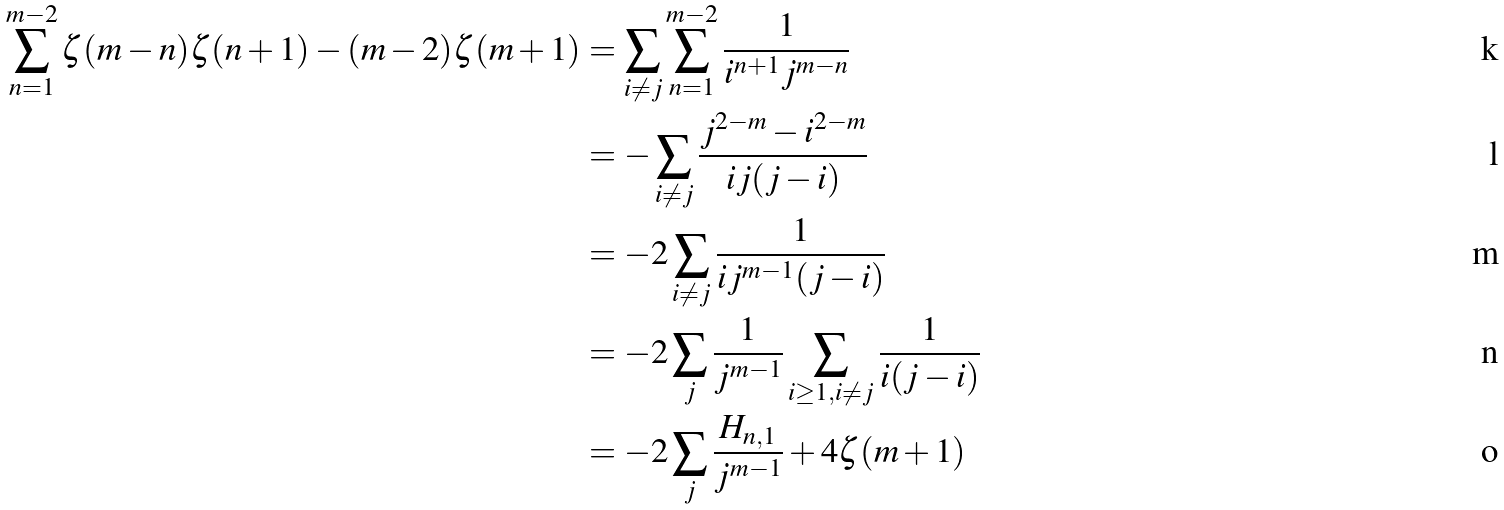Convert formula to latex. <formula><loc_0><loc_0><loc_500><loc_500>\sum _ { n = 1 } ^ { m - 2 } \zeta ( m - n ) \zeta ( n + 1 ) - ( m - 2 ) \zeta ( m + 1 ) & = \sum _ { i \neq j } \sum _ { n = 1 } ^ { m - 2 } \frac { 1 } { i ^ { n + 1 } j ^ { m - n } } \\ & = - \sum _ { i \neq j } \frac { j ^ { 2 - m } - i ^ { 2 - m } } { i j ( j - i ) } \\ & = - 2 \sum _ { i \neq j } \frac { 1 } { i j ^ { m - 1 } ( j - i ) } \\ & = - 2 \sum _ { j } \frac { 1 } { j ^ { m - 1 } } \sum _ { i \geq 1 , i \neq j } \frac { 1 } { i ( j - i ) } \\ & = - 2 \sum _ { j } \frac { H _ { n , 1 } } { j ^ { m - 1 } } + 4 \zeta ( m + 1 )</formula> 